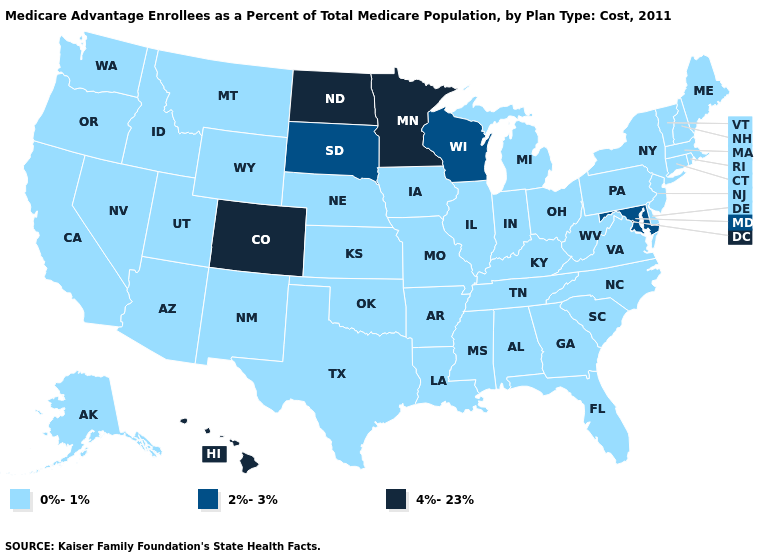How many symbols are there in the legend?
Short answer required. 3. Does Colorado have the highest value in the USA?
Quick response, please. Yes. Does the first symbol in the legend represent the smallest category?
Quick response, please. Yes. Among the states that border Pennsylvania , which have the lowest value?
Be succinct. Delaware, New Jersey, New York, Ohio, West Virginia. What is the lowest value in the Northeast?
Quick response, please. 0%-1%. What is the value of Hawaii?
Be succinct. 4%-23%. Name the states that have a value in the range 2%-3%?
Keep it brief. Maryland, South Dakota, Wisconsin. What is the highest value in the USA?
Be succinct. 4%-23%. Does Delaware have a lower value than New Mexico?
Write a very short answer. No. Does Wisconsin have a lower value than Michigan?
Write a very short answer. No. Name the states that have a value in the range 4%-23%?
Be succinct. Colorado, Hawaii, Minnesota, North Dakota. What is the lowest value in the USA?
Quick response, please. 0%-1%. Which states have the highest value in the USA?
Concise answer only. Colorado, Hawaii, Minnesota, North Dakota. Which states have the lowest value in the USA?
Give a very brief answer. Alaska, Alabama, Arkansas, Arizona, California, Connecticut, Delaware, Florida, Georgia, Iowa, Idaho, Illinois, Indiana, Kansas, Kentucky, Louisiana, Massachusetts, Maine, Michigan, Missouri, Mississippi, Montana, North Carolina, Nebraska, New Hampshire, New Jersey, New Mexico, Nevada, New York, Ohio, Oklahoma, Oregon, Pennsylvania, Rhode Island, South Carolina, Tennessee, Texas, Utah, Virginia, Vermont, Washington, West Virginia, Wyoming. 